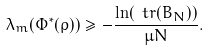Convert formula to latex. <formula><loc_0><loc_0><loc_500><loc_500>\lambda _ { m } ( \Phi ^ { \ast } ( \rho ) ) \geq - \frac { \ln ( \ t r ( B _ { N } ) ) } { \mu N } .</formula> 